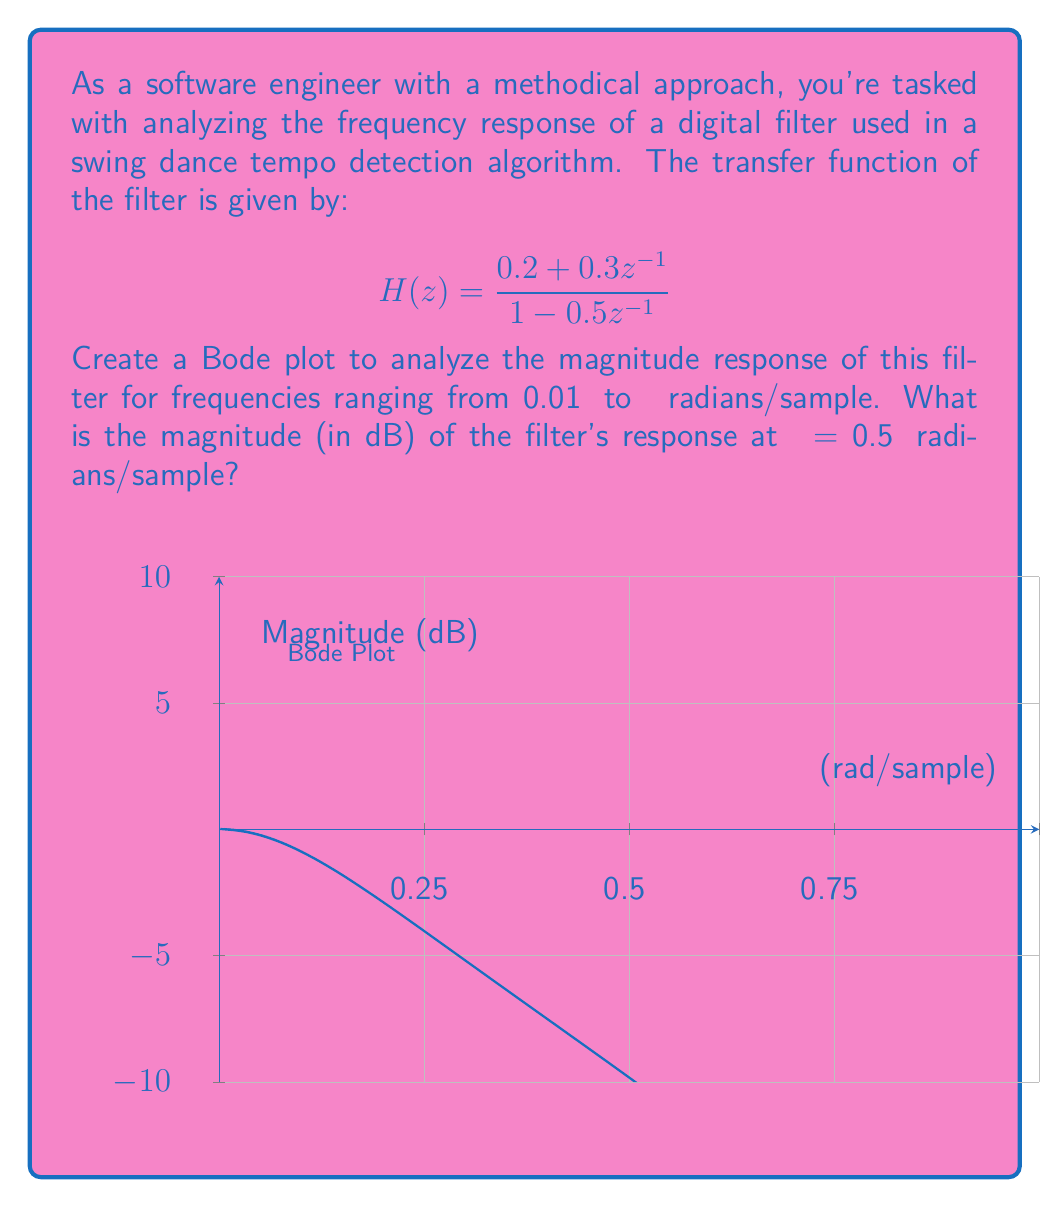Can you solve this math problem? To solve this problem, we'll follow these steps:

1) The transfer function in the z-domain is given as:
   $$ H(z) = \frac{0.2 + 0.3z^{-1}}{1 - 0.5z^{-1}} $$

2) To find the frequency response, we substitute $z = e^{jω}$:
   $$ H(e^{jω}) = \frac{0.2 + 0.3e^{-jω}}{1 - 0.5e^{-jω}} $$

3) The magnitude response is given by $|H(e^{jω})|$. We can calculate this as:
   $$ |H(e^{jω})| = \sqrt{\frac{(0.2 + 0.3\cos(ω))^2 + (0.3\sin(ω))^2}{(1 - 0.5\cos(ω))^2 + (0.5\sin(ω))^2}} $$

4) To convert to dB, we use the formula:
   $$ \text{Magnitude (dB)} = 20 \log_{10}(|H(e^{jω})|) $$

5) For ω = 0.5π radians/sample, we plug this value into our equation:
   $$ |H(e^{j0.5π})| = \sqrt{\frac{(0.2 + 0.3\cos(0.5π))^2 + (0.3\sin(0.5π))^2}{(1 - 0.5\cos(0.5π))^2 + (0.5\sin(0.5π))^2}} $$

6) Simplify:
   $$ |H(e^{j0.5π})| = \sqrt{\frac{0.2^2 + 0.3^2}{1 + 0.5^2}} = \sqrt{\frac{0.13}{1.25}} \approx 0.3225 $$

7) Convert to dB:
   $$ 20 \log_{10}(0.3225) \approx -9.83 \text{ dB} $$

Therefore, the magnitude of the filter's response at ω = 0.5π radians/sample is approximately -9.83 dB.
Answer: -9.83 dB 